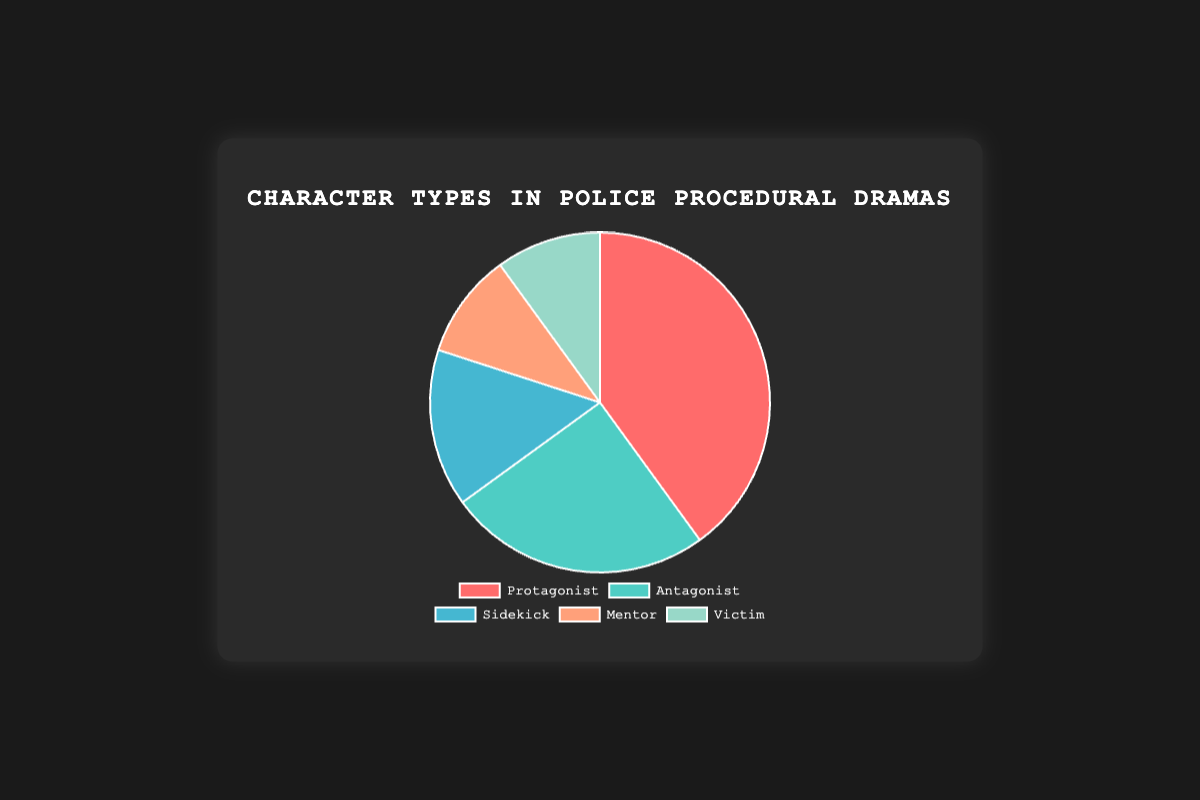What percentage of the character types are classified as Mentor and Victim combined? To find the combined percentage of Mentor and Victim, add the percentage values for these two categories: 10% (Mentor) + 10% (Victim) = 20%
Answer: 20% Which character type is the most prevalent in police procedural dramas? By looking at the pie chart, we can see that the largest segment belongs to the Protagonist with a percentage of 40%.
Answer: Protagonist Is the percentage of Sidekick characters greater than or less than that of Antagonist characters? The percentage of Sidekick characters is 15%, which is less than the percentage of Antagonist characters (25%).
Answer: Less than What color represents the Antagonist in the pie chart? By observing the pie chart, the segment for Antagonist is shown in a greenish-blue color.
Answer: Greenish-blue Which character type has the smallest percentage, and what is the percentage? By examining the pie chart, the smallest segments correspond to Mentor and Victim, each with a percentage value of 10%.
Answer: Mentor and Victim; 10% How much more prevalent is the Protagonist type compared to the Sidekick type? To find the difference in prevalence, subtract the percentage for the Sidekick (15%) from the percentage for the Protagonist (40%): 40% - 15% = 25%
Answer: 25% If each segment's percentage is doubled, what would be the new percentage value for the Antagonist? Doubling the Antagonist's original percentage of 25% gives: 25% * 2 = 50%
Answer: 50% Are there more characters classified as Mentors or as Victims? By looking at the pie chart, both Mentors and Victims have the same percentage, which is 10%.
Answer: Equal What is the combined percentage of Protagonist and Antagonist types, and what does this indicate about their dominance in the genre? To find the combined percentage, add the Protagonist (40%) and Antagonist (25%): 40% + 25% = 65%. This indicates that Protagonist and Antagonist types dominate the genre, comprising 65% of the characters.
Answer: 65% If a new character type called "Witness" is introduced with a 10% share, how will the chart look for the top three types? The top three types with the new addition would be Protagonist (40%), Antagonist (25%), and "Witness" with 10%, tied with Mentor and Victim, demonstrating the relative shares would remain similar for other top types. (However, this would need a recalibration of percentages across the chart.)
Answer: Protagonist (40%), Antagonist (25%), and Witness (10%) 